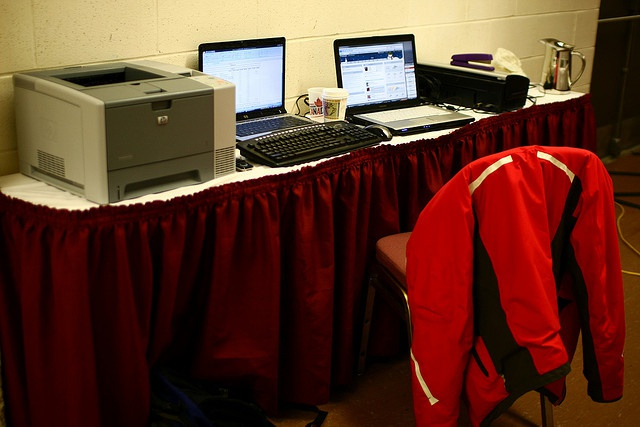Describe the objects in this image and their specific colors. I can see laptop in olive, white, black, darkgray, and lightblue tones, laptop in olive, lavender, black, lightblue, and navy tones, keyboard in olive, black, darkgreen, and gray tones, chair in olive, black, brown, and maroon tones, and keyboard in olive, navy, black, gray, and darkblue tones in this image. 